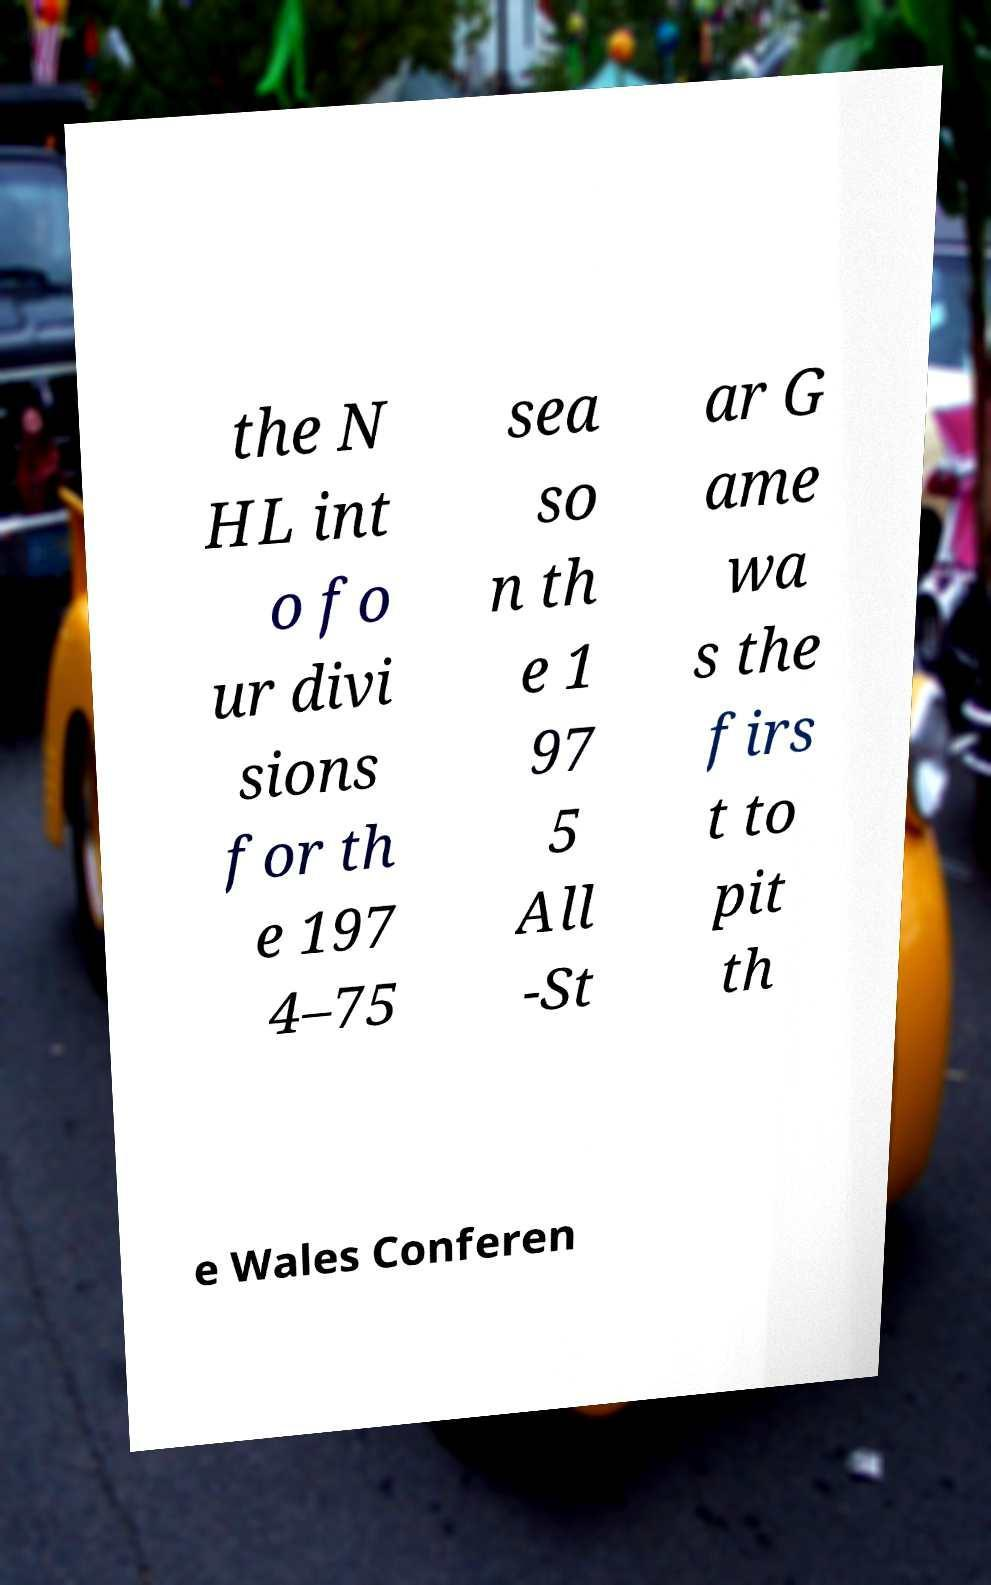What messages or text are displayed in this image? I need them in a readable, typed format. the N HL int o fo ur divi sions for th e 197 4–75 sea so n th e 1 97 5 All -St ar G ame wa s the firs t to pit th e Wales Conferen 